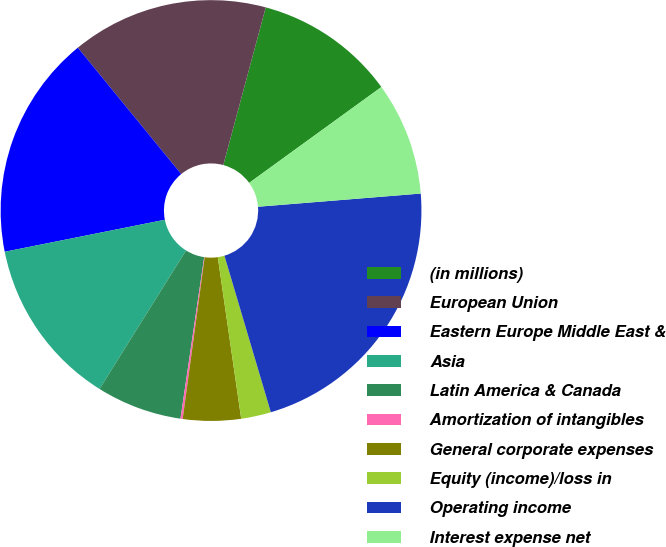<chart> <loc_0><loc_0><loc_500><loc_500><pie_chart><fcel>(in millions)<fcel>European Union<fcel>Eastern Europe Middle East &<fcel>Asia<fcel>Latin America & Canada<fcel>Amortization of intangibles<fcel>General corporate expenses<fcel>Equity (income)/loss in<fcel>Operating income<fcel>Interest expense net<nl><fcel>10.83%<fcel>15.1%<fcel>17.23%<fcel>12.97%<fcel>6.57%<fcel>0.17%<fcel>4.44%<fcel>2.3%<fcel>21.7%<fcel>8.7%<nl></chart> 